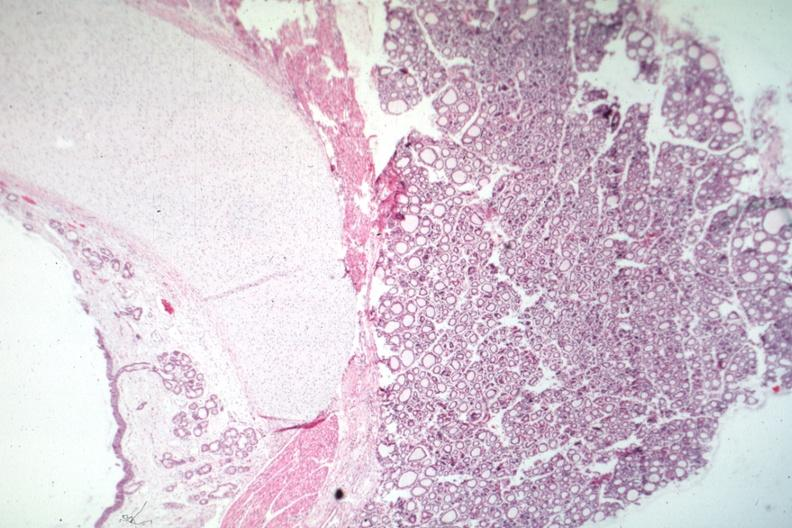where is this part in the figure?
Answer the question using a single word or phrase. Endocrine system 